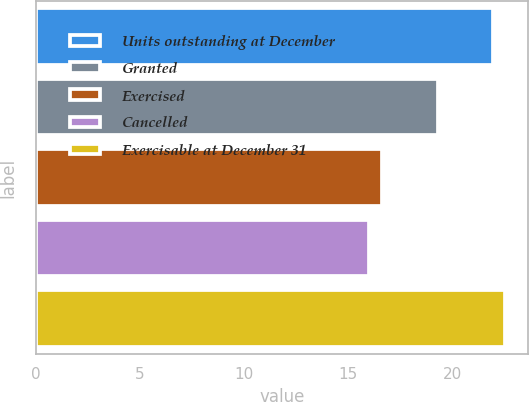Convert chart. <chart><loc_0><loc_0><loc_500><loc_500><bar_chart><fcel>Units outstanding at December<fcel>Granted<fcel>Exercised<fcel>Cancelled<fcel>Exercisable at December 31<nl><fcel>21.94<fcel>19.3<fcel>16.61<fcel>16.02<fcel>22.53<nl></chart> 